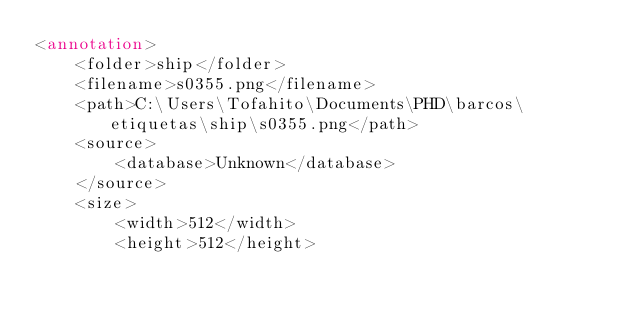<code> <loc_0><loc_0><loc_500><loc_500><_XML_><annotation>
	<folder>ship</folder>
	<filename>s0355.png</filename>
	<path>C:\Users\Tofahito\Documents\PHD\barcos\etiquetas\ship\s0355.png</path>
	<source>
		<database>Unknown</database>
	</source>
	<size>
		<width>512</width>
		<height>512</height></code> 